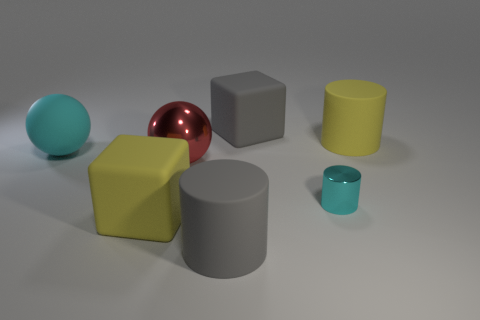There is a rubber block to the right of the gray cylinder; what size is it?
Provide a succinct answer. Large. There is a block in front of the red thing; is its color the same as the big rubber cylinder that is behind the yellow rubber cube?
Your response must be concise. Yes. What number of other objects are there of the same shape as the small metallic object?
Your answer should be very brief. 2. Are there the same number of rubber blocks that are in front of the large gray block and metallic spheres in front of the big red shiny sphere?
Keep it short and to the point. No. Does the ball behind the large red object have the same material as the block that is in front of the cyan matte thing?
Your answer should be compact. Yes. How many other objects are the same size as the gray cube?
Ensure brevity in your answer.  5. What number of things are either gray metal cylinders or metallic objects to the left of the shiny cylinder?
Your response must be concise. 1. Is the number of big yellow rubber blocks in front of the large yellow cylinder the same as the number of big red things?
Make the answer very short. Yes. There is a big yellow thing that is made of the same material as the yellow cylinder; what shape is it?
Provide a short and direct response. Cube. Are there any big things that have the same color as the metal cylinder?
Offer a very short reply. Yes. 